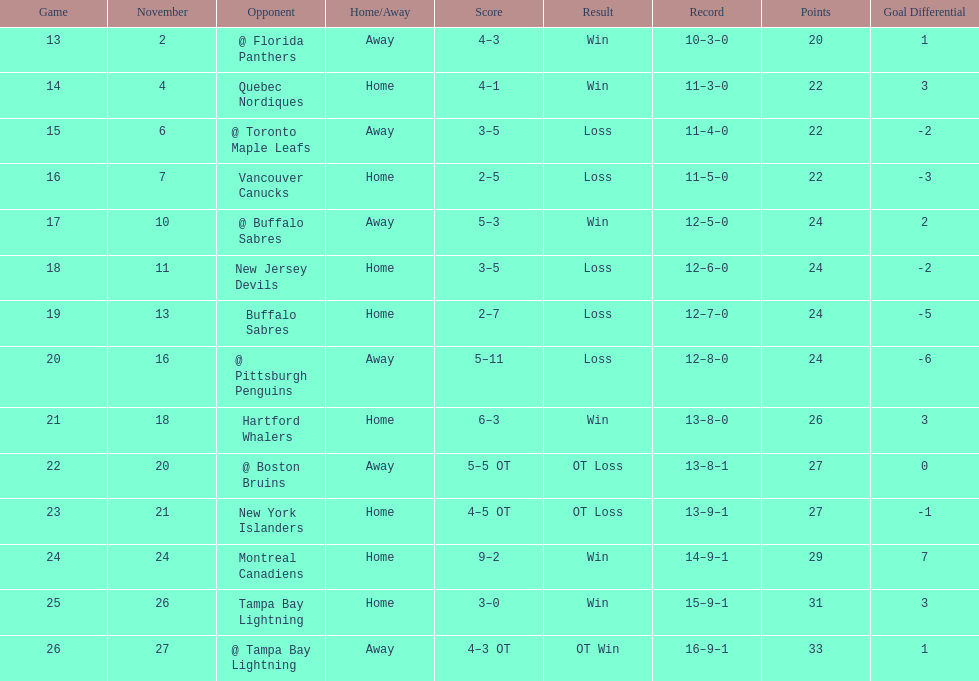Did the tampa bay lightning have the least amount of wins? Yes. 